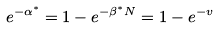Convert formula to latex. <formula><loc_0><loc_0><loc_500><loc_500>{ } e ^ { - \alpha ^ { * } } = 1 - e ^ { - \beta ^ { * } N } = 1 - e ^ { - v }</formula> 